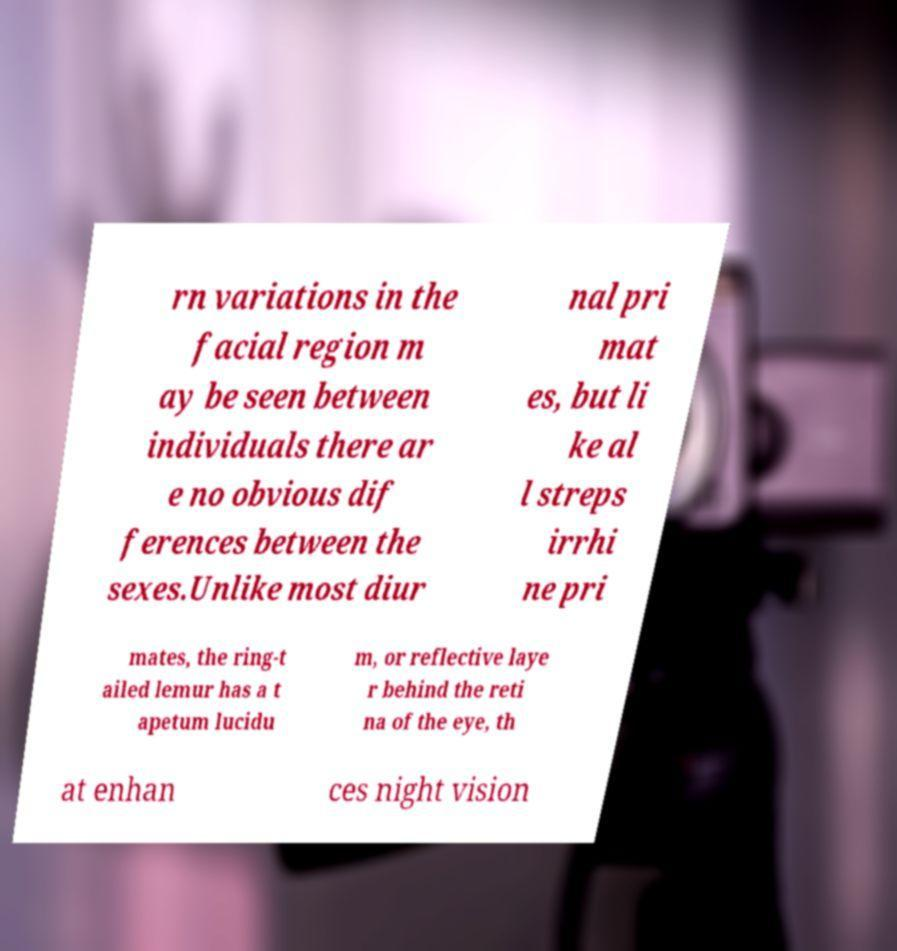Please read and relay the text visible in this image. What does it say? rn variations in the facial region m ay be seen between individuals there ar e no obvious dif ferences between the sexes.Unlike most diur nal pri mat es, but li ke al l streps irrhi ne pri mates, the ring-t ailed lemur has a t apetum lucidu m, or reflective laye r behind the reti na of the eye, th at enhan ces night vision 